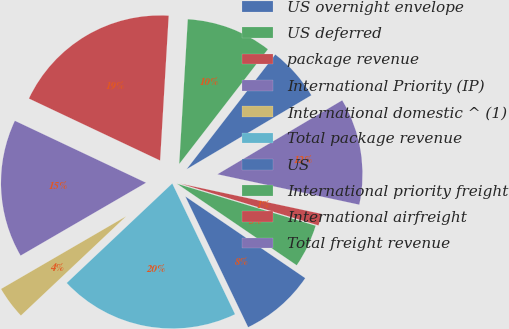<chart> <loc_0><loc_0><loc_500><loc_500><pie_chart><fcel>US overnight envelope<fcel>US deferred<fcel>package revenue<fcel>International Priority (IP)<fcel>International domestic ^ (1)<fcel>Total package revenue<fcel>US<fcel>International priority freight<fcel>International airfreight<fcel>Total freight revenue<nl><fcel>6.01%<fcel>9.53%<fcel>18.92%<fcel>15.4%<fcel>3.66%<fcel>20.09%<fcel>8.36%<fcel>4.84%<fcel>1.32%<fcel>11.88%<nl></chart> 